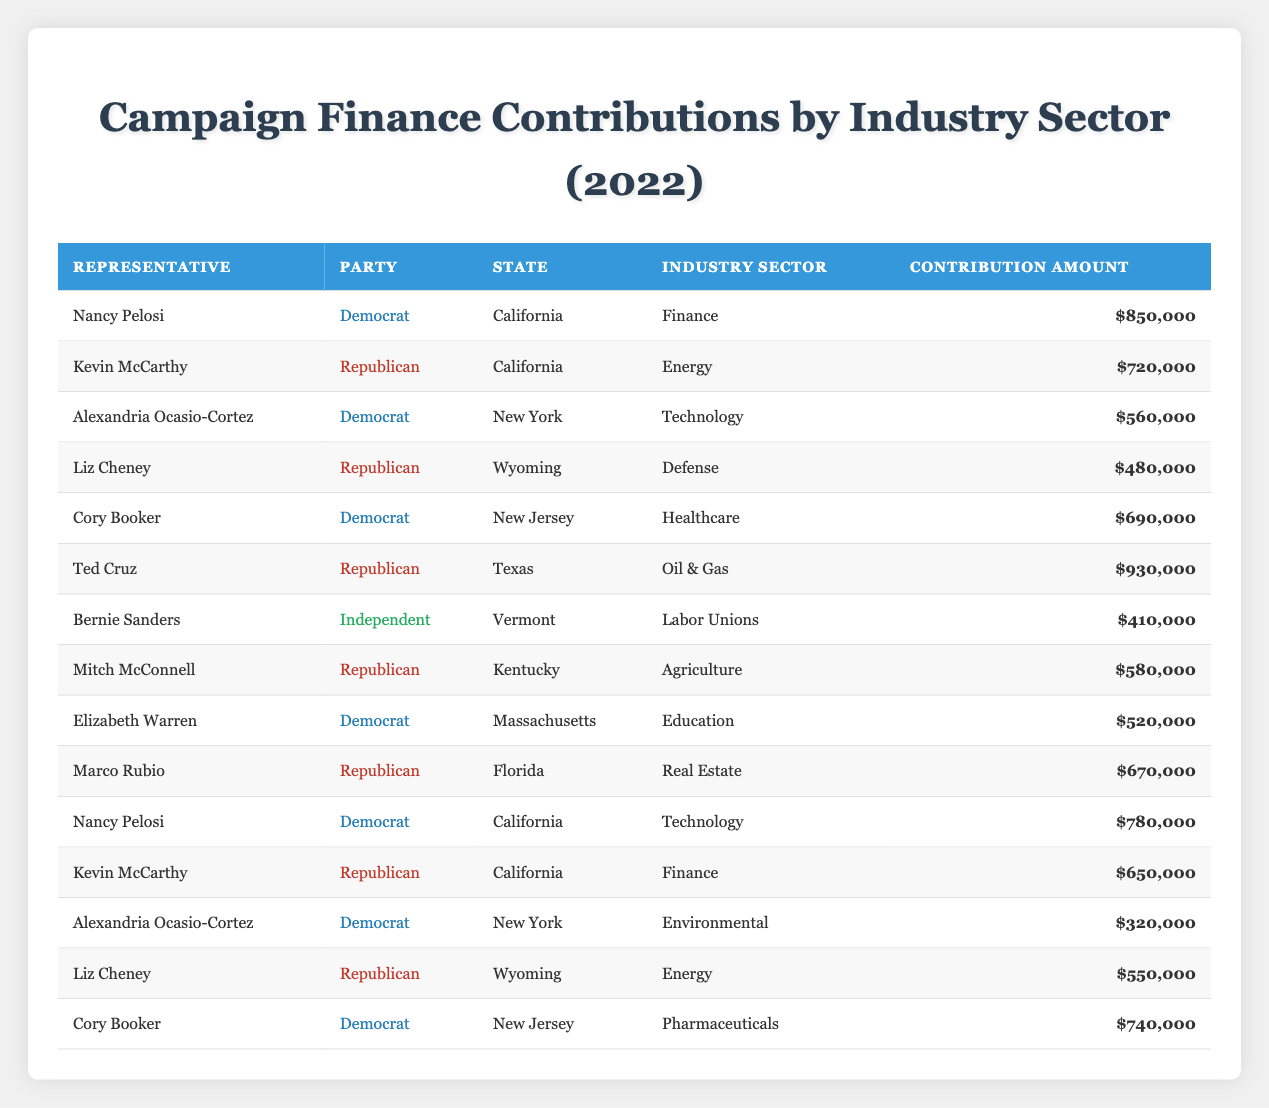What was the total contribution amount from the healthcare industry sector? To find the total contribution amount from the healthcare industry sector, we look at the rows under that sector. Only Cory Booker contributed $690,000. Thus, the total is $690,000.
Answer: $690,000 Which representative received the highest contributions from the finance industry? Looking at the finance industry sector, Nancy Pelosi received a contribution of $850,000 and Kevin McCarthy received $650,000. Therefore, Nancy Pelosi received the highest contributions from this sector.
Answer: Nancy Pelosi Is it true that all Democrats received contributions from the technology sector? There are three Democrats: Nancy Pelosi, Alexandria Ocasio-Cortez, and both received contributions from technology, totaling $1,340,000. However, there is ambiguity about whether all Democrats received contributions from this sector since we only see two individuals listed. Thus, the statement is partially true but not fully verified.
Answer: No What is the average contribution amount across all representatives from the energy industry sector? There are two contributions in the energy sector: Kevin McCarthy's $720,000 and Liz Cheney's $550,000. The total contribution is $720,000 + $550,000 = $1,270,000. There are 2 representatives, so the average contribution is $1,270,000 / 2 = $635,000.
Answer: $635,000 How many representatives received contributions from the oil and gas industry? Only one representative, Ted Cruz, received contributions from the oil & gas industry, which amounted to $930,000. Therefore, there is only one representative in this category.
Answer: 1 Which industry sector received the highest overall contribution total? Looking at the contributions, we sum each industry sector: Finance ($1,500,000), Energy ($1,270,000), Technology ($1,340,000), Defense ($480,000), Healthcare ($690,000), Oil & Gas ($930,000), Labor Unions ($410,000), Agriculture ($580,000), Education ($520,000), Real Estate ($670,000), Environmental ($320,000), and Pharmaceuticals ($740,000). The highest is in Finance with a total of $1,500,000.
Answer: Finance What is the contribution difference between the highest and lowest contributions from the pharmaceutical industry sector? The pharmaceutical sector contribution is $740,000 from Cory Booker, and there are no other representatives in that sector, making that the only entry leading to no comparison. Thus, the difference cannot be calculated.
Answer: N/A Did Alexandria Ocasio-Cortez receive more total contributions than Liz Cheney? Alexandria Ocasio-Cortez received contributions totaling $560,000 (Technology) and $320,000 (Environmental), totaling $880,000. Liz Cheney received $480,000 (Defense) and $550,000 (Energy), totaling $1,030,000. Comparing these totals, Liz Cheney received more contributions.
Answer: No 